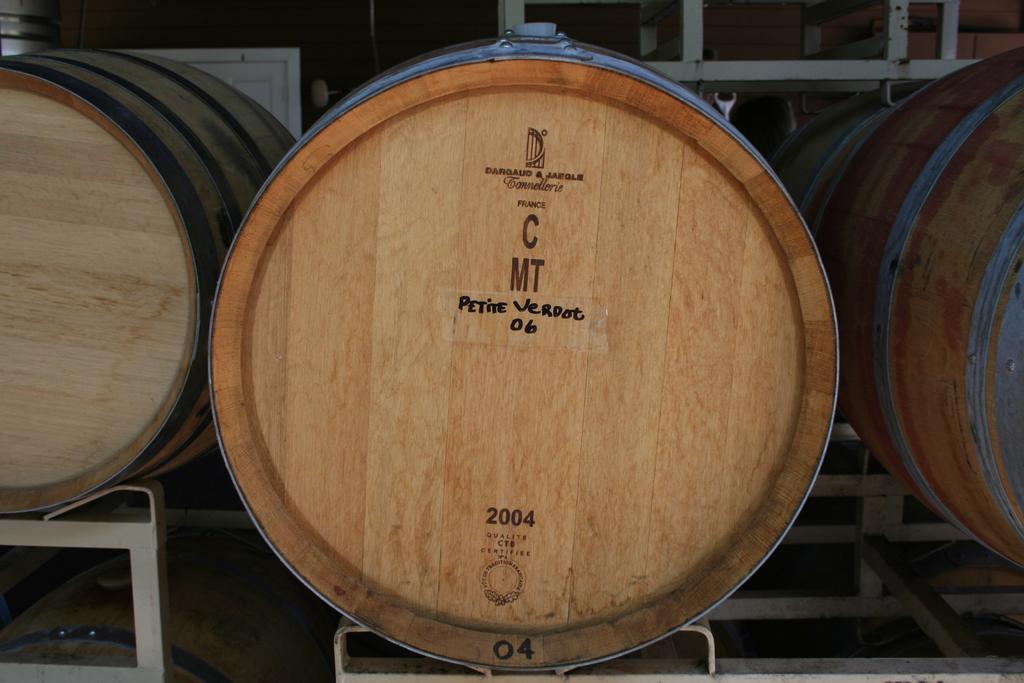How would you summarize this image in a sentence or two? In this picture we can see wood. 